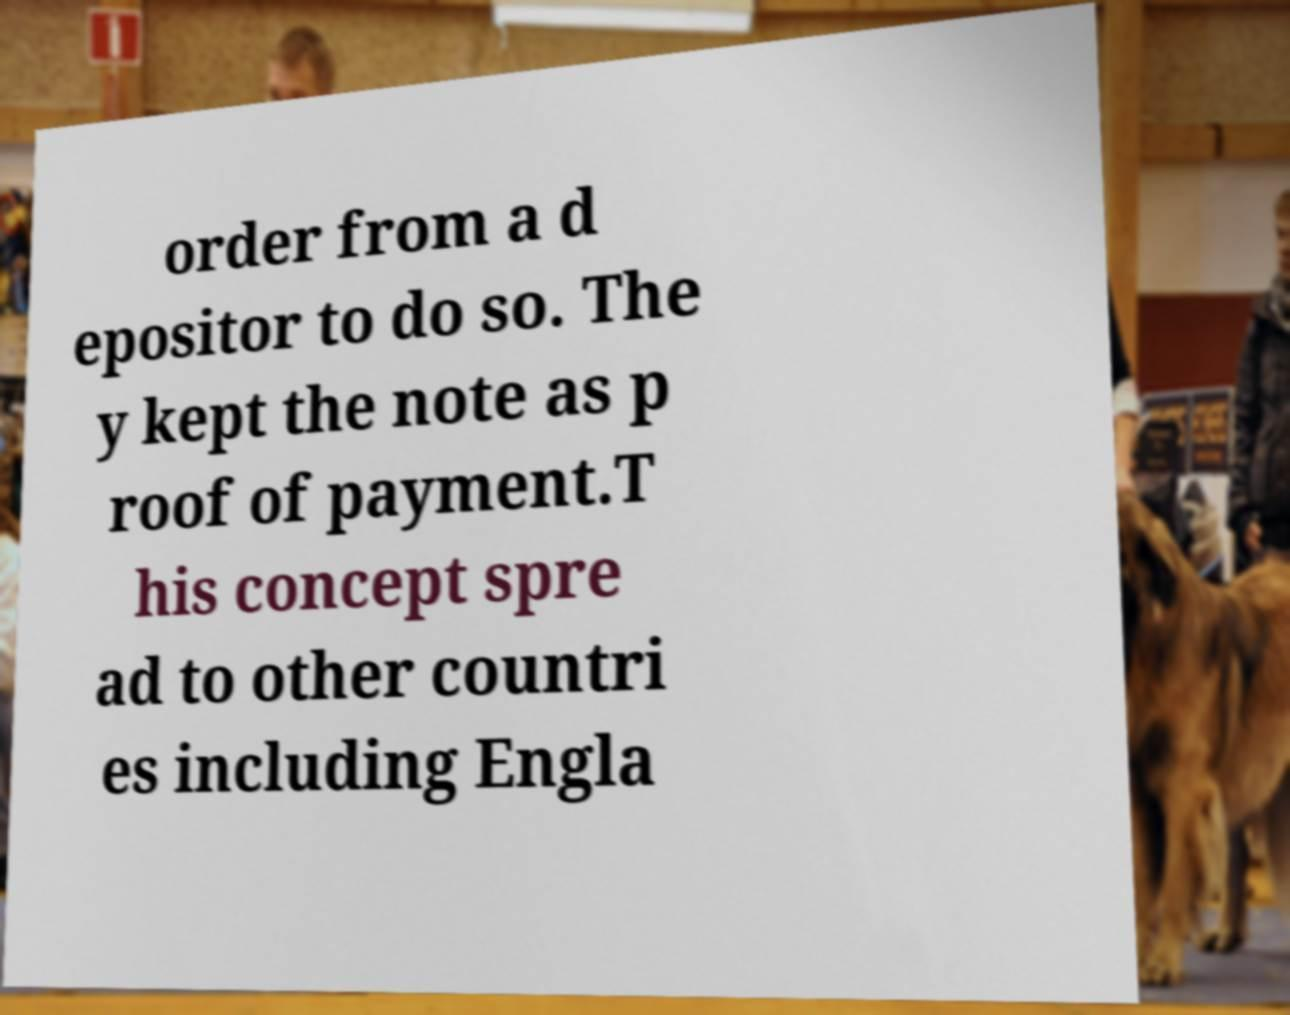Can you accurately transcribe the text from the provided image for me? order from a d epositor to do so. The y kept the note as p roof of payment.T his concept spre ad to other countri es including Engla 